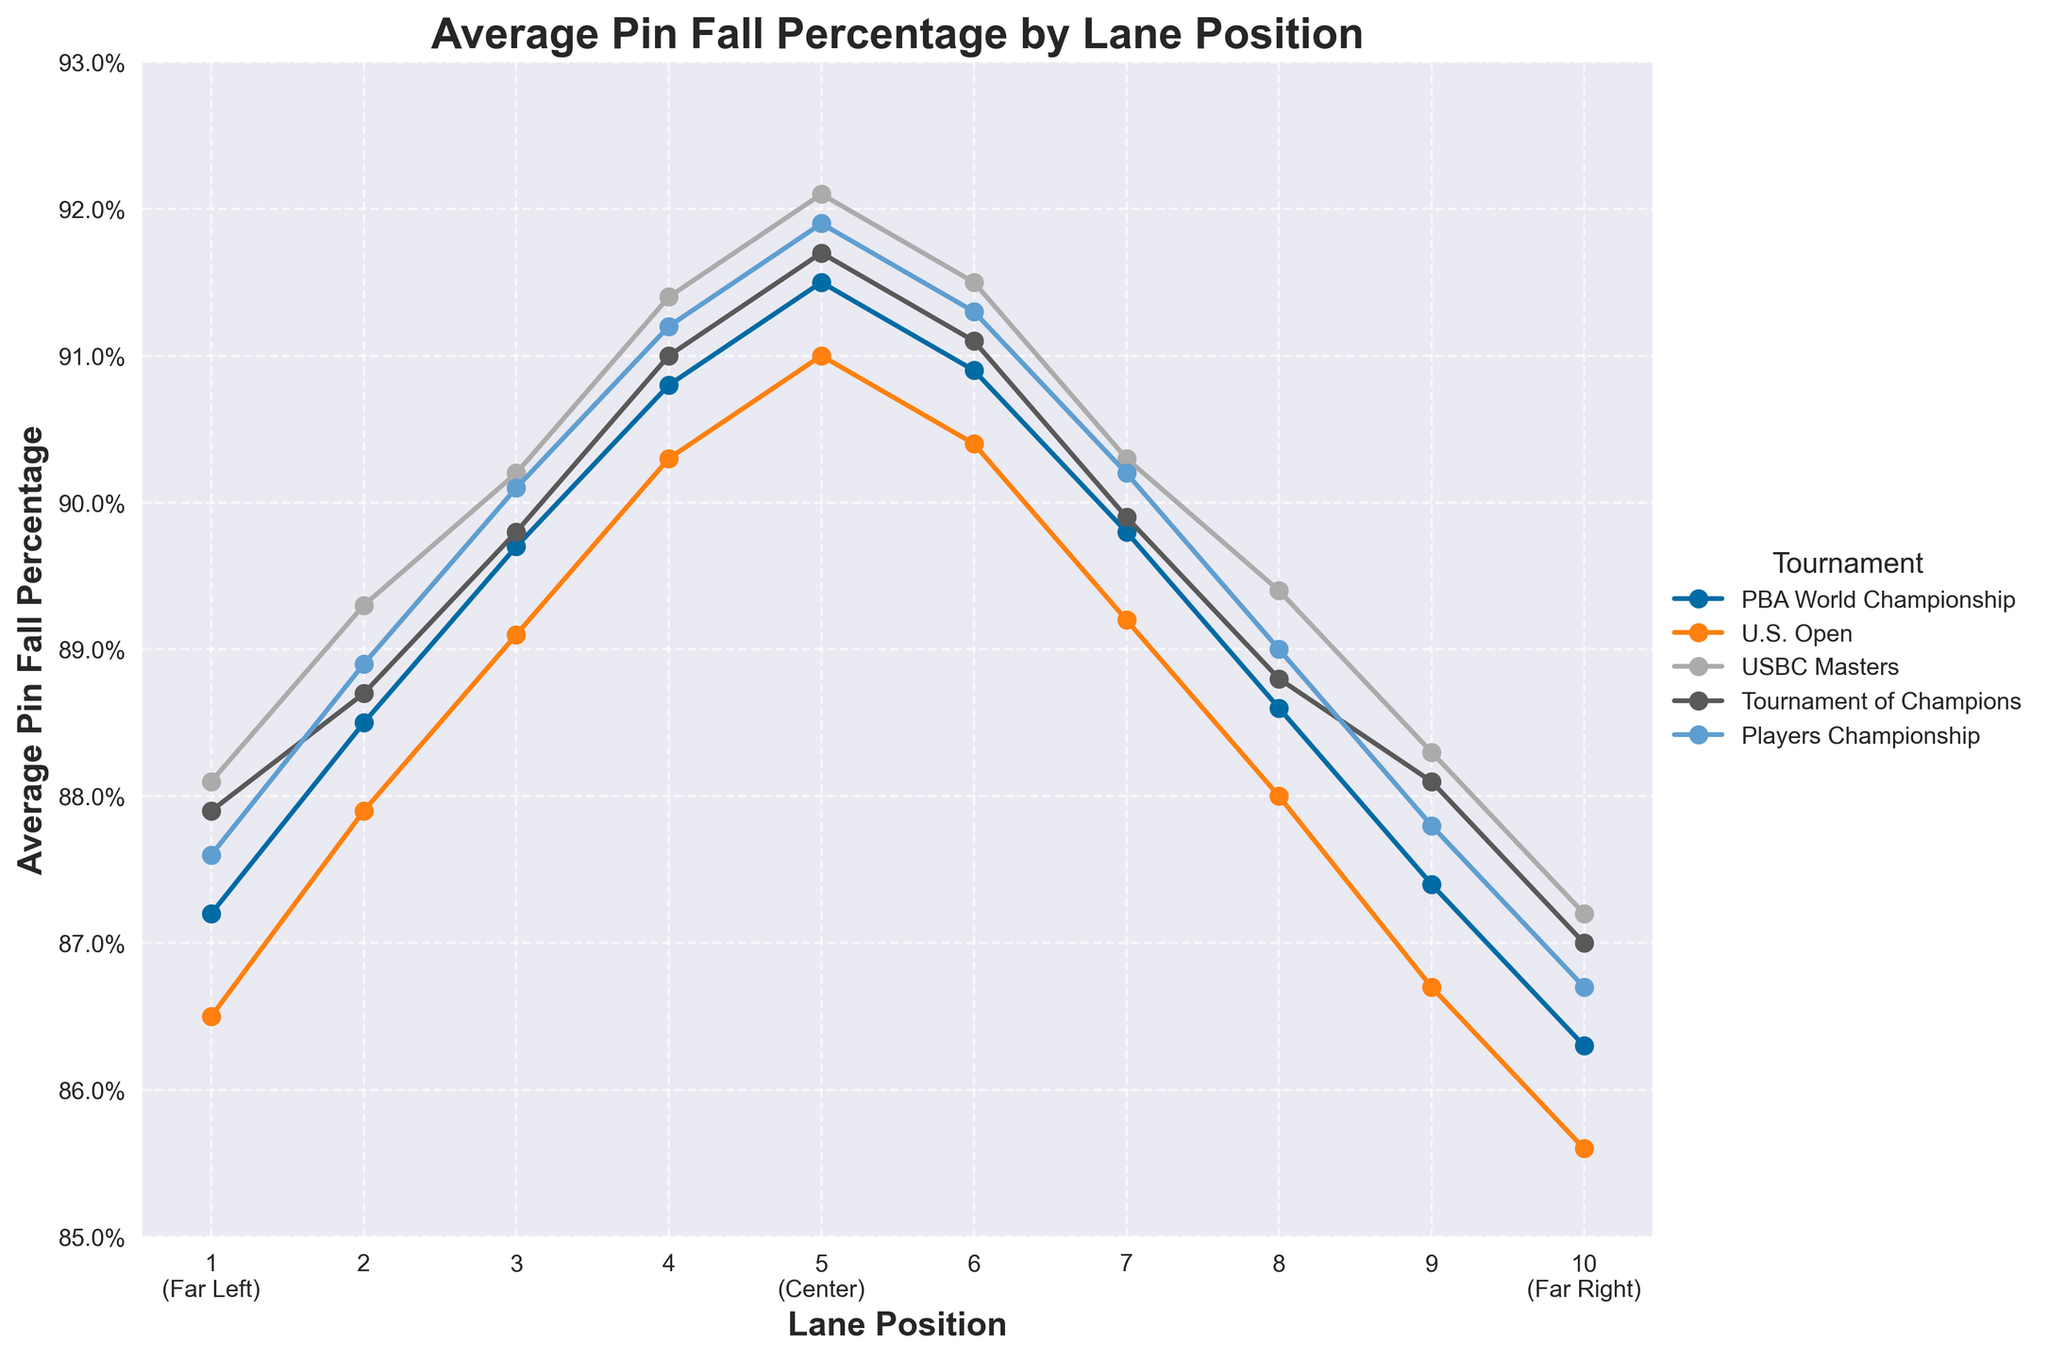What's the lane position with the highest average pin fall percentage in the Player's Championship? The highest average pin fall percentage for the Player's Championship is seen in lane position 5 with a value of 91.9%. Scan through the values of the Player's Championship column to identify the highest percentage.
Answer: 5 Which lane position performs consistently well across all tournaments? Lane position 5 performs consistently well across all tournaments, as it shows the highest or nearly highest pin fall percentage in all the given tournaments. Look at each column and observe lane position 5's values, which are consistently high.
Answer: 5 What is the difference in average pin fall percentage between lane position 5 and lane position 1 for the USBC Masters? For lane position 5, the pin fall percentage is 92.1% and for lane position 1, it is 88.1%. Calculate the difference: 92.1 - 88.1 = 4.
Answer: 4 Which tournament shows the largest range of average pin fall percentages across different lane positions? The range can be calculated by subtracting the smallest pin fall percentage from the largest pin fall percentage for each tournament. For the PBA World Championship: 91.5 - 86.3 = 5.2. For the U.S. Open: 91.0 - 85.6 = 5.4. For the USBC Masters: 92.1 - 87.2 = 4.9. For the Tournament of Champions: 91.7 - 87.0 = 4.7. For the Players Championship: 91.9 - 86.7 = 5.2. The U.S. Open has the largest range.
Answer: U.S. Open Is there a lane position that shows a noticeable drop in performance compared to its neighbors? Lane position 10 (Far Right) shows a noticeable drop in performance compared to its neighboring lane positions (9 and 1). For example, in the PBA World Championship, lane 10 has 86.3% while lane 9 has 87.4% and lane 1 has 87.2%. The percentages drop more on lane 10 compared to its adjacent lanes across most tournaments.
Answer: 10 (Far Right) In the context of the U.S. Open, compare the performance of lane positions 3 and 7. Which one has a better average pin fall percentage and by how much? In the U.S. Open, lane position 3 has an average pin fall percentage of 89.1%, and lane position 7 has 89.2%. The better performance is seen in lane position 7, but the difference is slight: 89.2 - 89.1 = 0.1%.
Answer: Lane 7 by 0.1 Considering all tournaments, which lane position shows the most significant improvement relative to its center lane (5)? Lane position 4 shows significant improvement relative to lane position 5 when moving from lane 3. For instance, in the USBC Masters, lane 4 improves to 91.4% from lane 3's 90.2%, and similarly, lane 4 consistently shows high percentages approaching the central lane 5. Scan each tournament dataset and observe how lane 4 consistently increases towards lane 5 values.
Answer: Lane 4 Which tournament has the least variation in pin fall percentage as you move across lane positions? Calculate the variation for each tournament by observing the differences in percentages across lane positions. The USBC Masters shows the smallest range of difference (92.1% at lane 5 and 87.2% at lane 10), suggesting lesser variation.
Answer: USBC Masters 